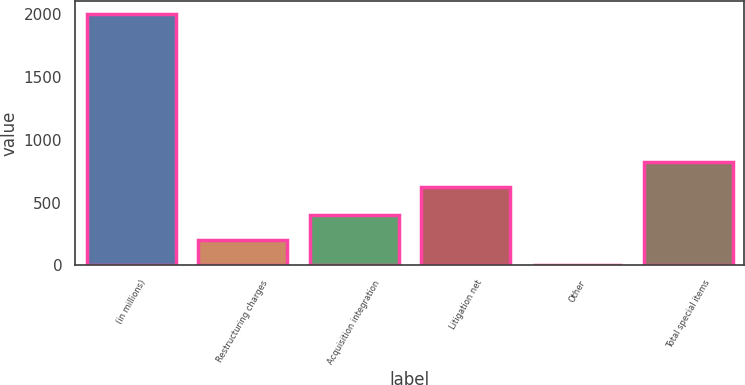<chart> <loc_0><loc_0><loc_500><loc_500><bar_chart><fcel>(in millions)<fcel>Restructuring charges<fcel>Acquisition integration<fcel>Litigation net<fcel>Other<fcel>Total special items<nl><fcel>2007<fcel>204.66<fcel>404.92<fcel>626<fcel>4.4<fcel>826.26<nl></chart> 